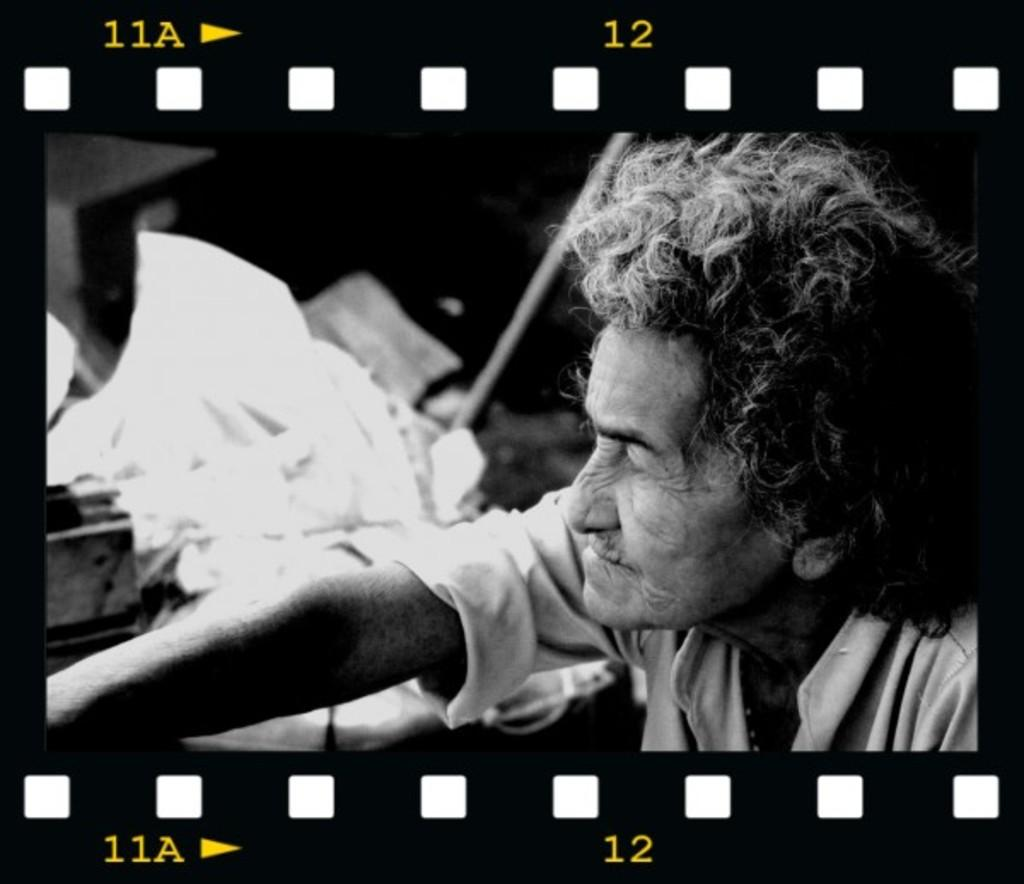What is the color scheme of the photo? The photo is black and white. Can you describe the main subject in the photo? There is a person in the photo. What else can be seen in the photo besides the person? There are objects and text in the photo. What type of truck is featured in the story depicted in the photo? There is no truck or story present in the photo; it is a black and white image with a person, objects, and text. 